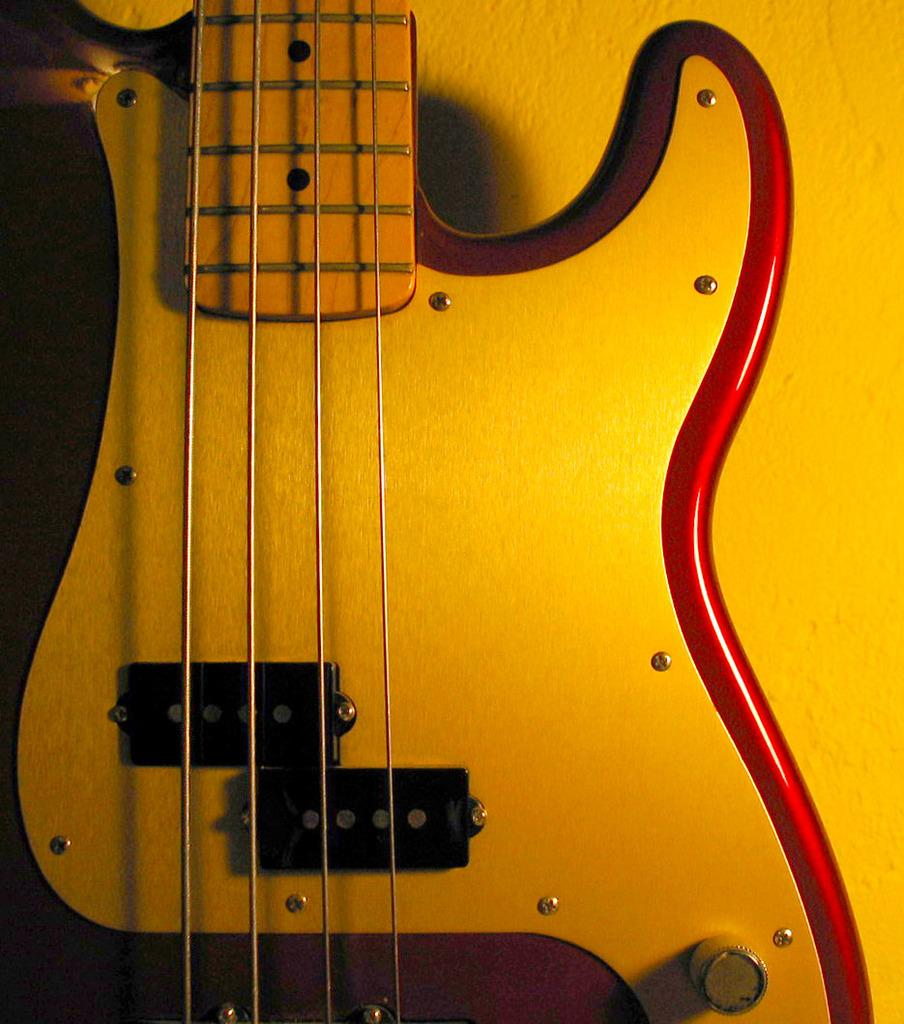What musical instrument is present in the image? There is a violin in the image. What colors are present on the violin? The violin has yellow and red color. How many strings does the violin have? The violin has four strings. What type of flag is being waved by the violin in the image? There is no flag present in the image, and the violin is not capable of waving anything. 